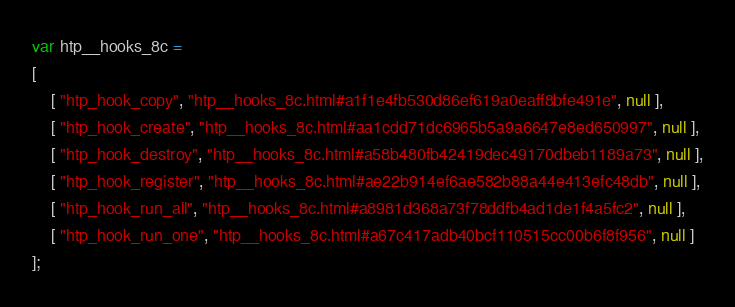Convert code to text. <code><loc_0><loc_0><loc_500><loc_500><_JavaScript_>var htp__hooks_8c =
[
    [ "htp_hook_copy", "htp__hooks_8c.html#a1f1e4fb530d86ef619a0eaff8bfe491e", null ],
    [ "htp_hook_create", "htp__hooks_8c.html#aa1cdd71dc6965b5a9a6647e8ed650997", null ],
    [ "htp_hook_destroy", "htp__hooks_8c.html#a58b480fb42419dec49170dbeb1189a73", null ],
    [ "htp_hook_register", "htp__hooks_8c.html#ae22b914ef6ae582b88a44e413efc48db", null ],
    [ "htp_hook_run_all", "htp__hooks_8c.html#a8981d368a73f78ddfb4ad1de1f4a5fc2", null ],
    [ "htp_hook_run_one", "htp__hooks_8c.html#a67c417adb40bcf110515cc00b6f8f956", null ]
];</code> 